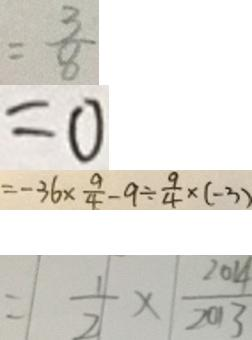Convert formula to latex. <formula><loc_0><loc_0><loc_500><loc_500>= \frac { 3 } { 8 } 
 = 0 
 = - 3 6 \times \frac { 9 } { 4 } - 9 \div \frac { 9 } { 4 } \times ( - 3 ) 
 = \frac { 1 } { 2 } \times \frac { 2 0 1 4 } { 2 0 1 3 }</formula> 